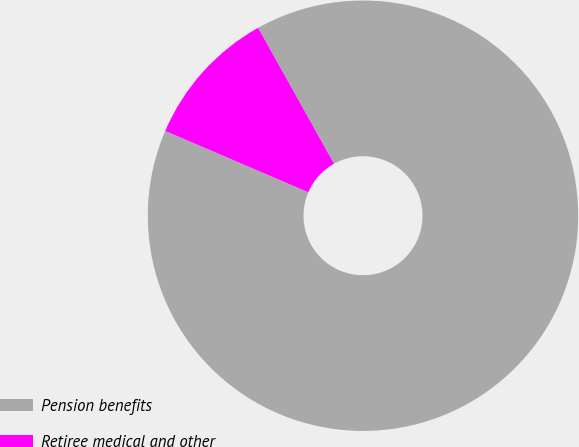<chart> <loc_0><loc_0><loc_500><loc_500><pie_chart><fcel>Pension benefits<fcel>Retiree medical and other<nl><fcel>89.55%<fcel>10.45%<nl></chart> 